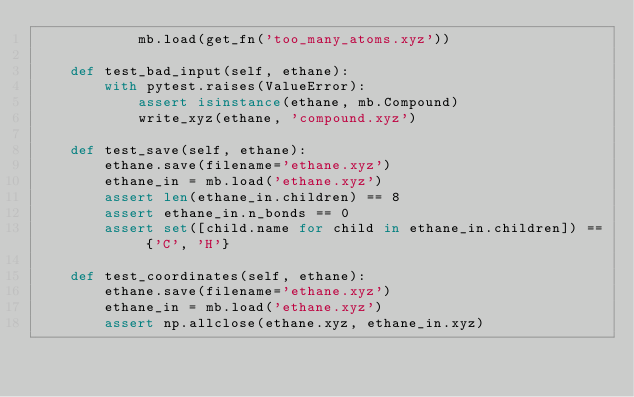Convert code to text. <code><loc_0><loc_0><loc_500><loc_500><_Python_>            mb.load(get_fn('too_many_atoms.xyz'))

    def test_bad_input(self, ethane):
        with pytest.raises(ValueError):
            assert isinstance(ethane, mb.Compound)
            write_xyz(ethane, 'compound.xyz')

    def test_save(self, ethane):
        ethane.save(filename='ethane.xyz')
        ethane_in = mb.load('ethane.xyz')
        assert len(ethane_in.children) == 8
        assert ethane_in.n_bonds == 0
        assert set([child.name for child in ethane_in.children]) == {'C', 'H'}

    def test_coordinates(self, ethane):
        ethane.save(filename='ethane.xyz')
        ethane_in = mb.load('ethane.xyz')
        assert np.allclose(ethane.xyz, ethane_in.xyz)
</code> 